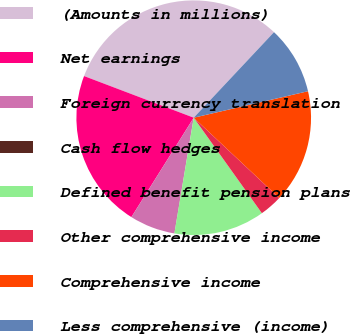Convert chart. <chart><loc_0><loc_0><loc_500><loc_500><pie_chart><fcel>(Amounts in millions)<fcel>Net earnings<fcel>Foreign currency translation<fcel>Cash flow hedges<fcel>Defined benefit pension plans<fcel>Other comprehensive income<fcel>Comprehensive income<fcel>Less comprehensive (income)<nl><fcel>31.22%<fcel>21.86%<fcel>6.26%<fcel>0.02%<fcel>12.5%<fcel>3.14%<fcel>15.62%<fcel>9.38%<nl></chart> 